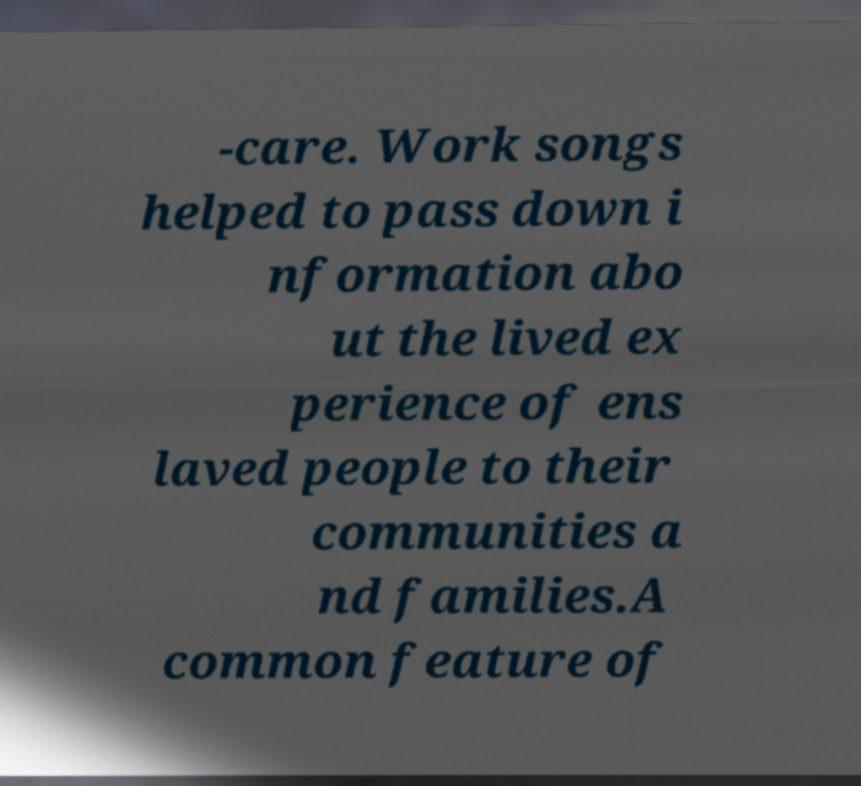Could you extract and type out the text from this image? -care. Work songs helped to pass down i nformation abo ut the lived ex perience of ens laved people to their communities a nd families.A common feature of 